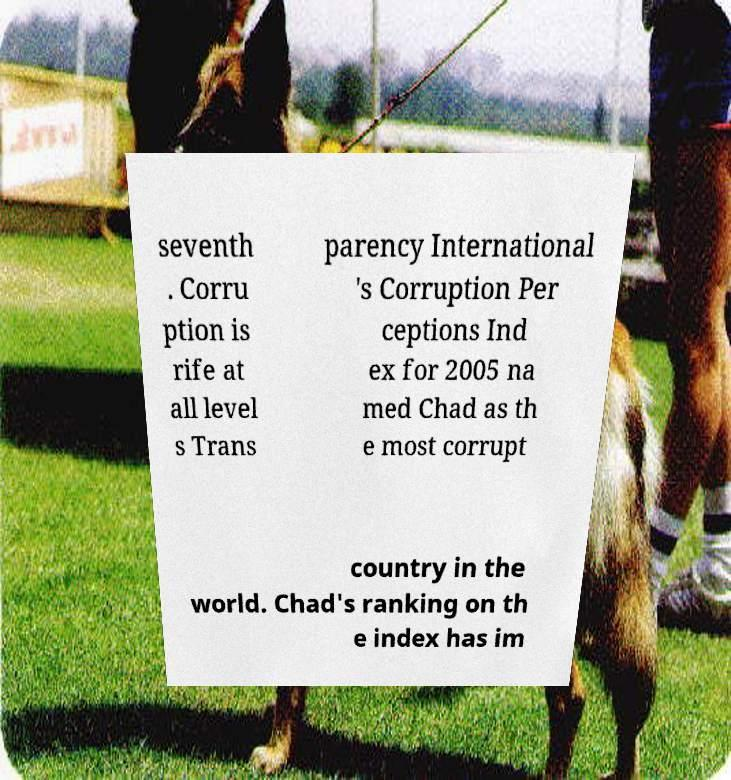Please read and relay the text visible in this image. What does it say? seventh . Corru ption is rife at all level s Trans parency International 's Corruption Per ceptions Ind ex for 2005 na med Chad as th e most corrupt country in the world. Chad's ranking on th e index has im 